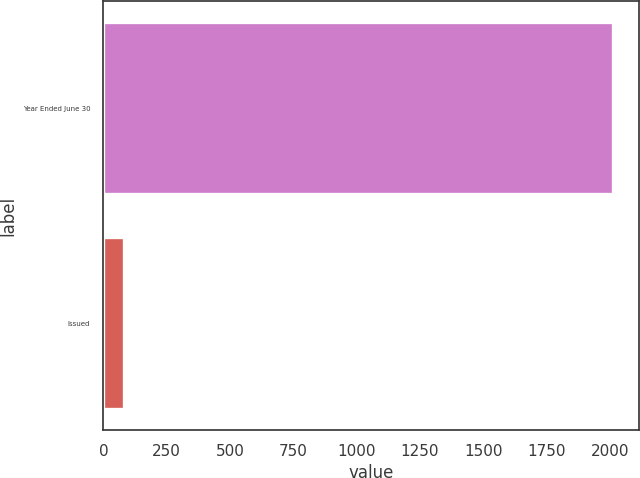Convert chart. <chart><loc_0><loc_0><loc_500><loc_500><bar_chart><fcel>Year Ended June 30<fcel>Issued<nl><fcel>2015<fcel>83<nl></chart> 